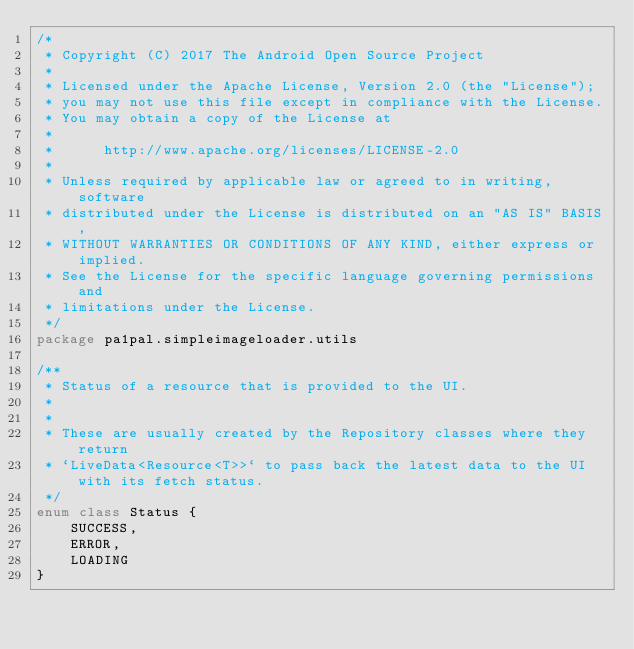Convert code to text. <code><loc_0><loc_0><loc_500><loc_500><_Kotlin_>/*
 * Copyright (C) 2017 The Android Open Source Project
 *
 * Licensed under the Apache License, Version 2.0 (the "License");
 * you may not use this file except in compliance with the License.
 * You may obtain a copy of the License at
 *
 *      http://www.apache.org/licenses/LICENSE-2.0
 *
 * Unless required by applicable law or agreed to in writing, software
 * distributed under the License is distributed on an "AS IS" BASIS,
 * WITHOUT WARRANTIES OR CONDITIONS OF ANY KIND, either express or implied.
 * See the License for the specific language governing permissions and
 * limitations under the License.
 */
package pa1pal.simpleimageloader.utils

/**
 * Status of a resource that is provided to the UI.
 *
 *
 * These are usually created by the Repository classes where they return
 * `LiveData<Resource<T>>` to pass back the latest data to the UI with its fetch status.
 */
enum class Status {
    SUCCESS,
    ERROR,
    LOADING
}
</code> 